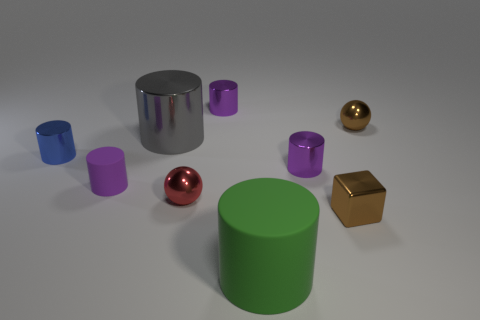Subtract all brown spheres. How many purple cylinders are left? 3 Subtract 1 cylinders. How many cylinders are left? 5 Subtract all purple cylinders. How many cylinders are left? 3 Subtract all big metal cylinders. How many cylinders are left? 5 Subtract all gray cylinders. Subtract all brown cubes. How many cylinders are left? 5 Add 1 brown spheres. How many objects exist? 10 Subtract all balls. How many objects are left? 7 Subtract all tiny brown cubes. Subtract all large gray metallic cubes. How many objects are left? 8 Add 6 large green rubber cylinders. How many large green rubber cylinders are left? 7 Add 5 brown balls. How many brown balls exist? 6 